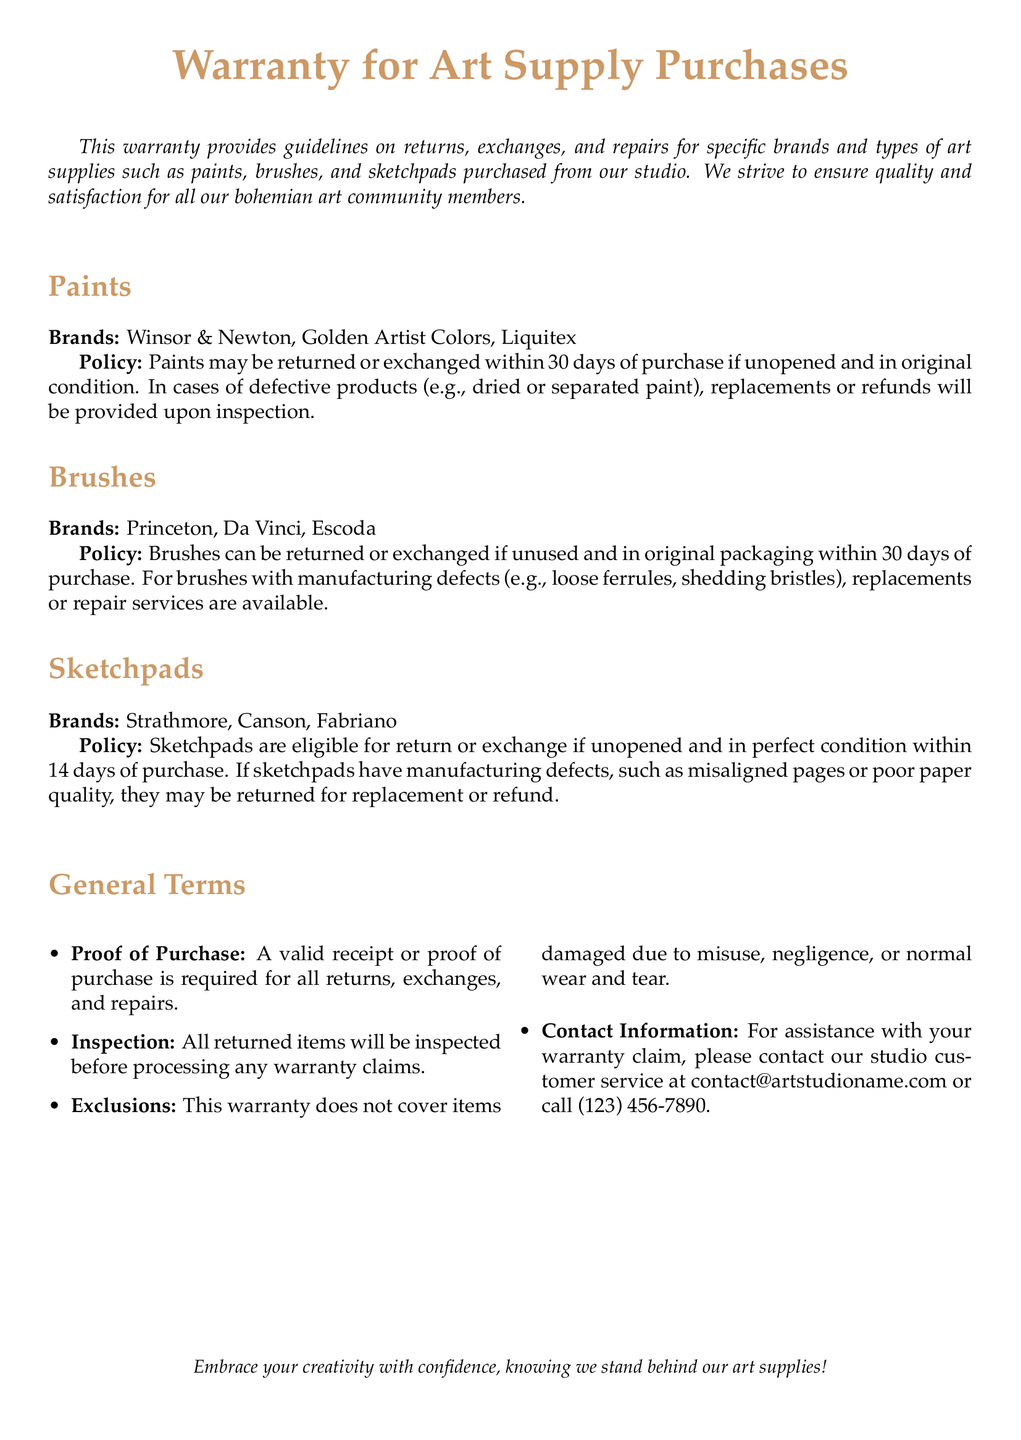What is the return period for paints? The document states that paints may be returned or exchanged within 30 days of purchase if unopened.
Answer: 30 days Which brands of sketchpads are mentioned? The document lists Strathmore, Canson, and Fabriano as brands for sketchpads.
Answer: Strathmore, Canson, Fabriano What condition must brushes be in to be eligible for return? Brushes must be unused and in the original packaging to qualify for return or exchange.
Answer: Unused and in original packaging What is required for processing a warranty claim? The document specifies that a valid receipt or proof of purchase is required for all returns and claims.
Answer: Valid receipt or proof of purchase How long do you have to return sketchpads? The warranty states that sketchpads can be returned within 14 days of purchase if unopened.
Answer: 14 days What type of defects does the warranty cover for paints? The warranty covers defects such as dried or separated paint for paints.
Answer: Dried or separated paint What happens to returned items? The document mentions that all returned items will be inspected before warranty claims are processed.
Answer: Inspected Is misuse covered under the warranty? The warranty clearly states that it does not cover items damaged due to misuse.
Answer: No 